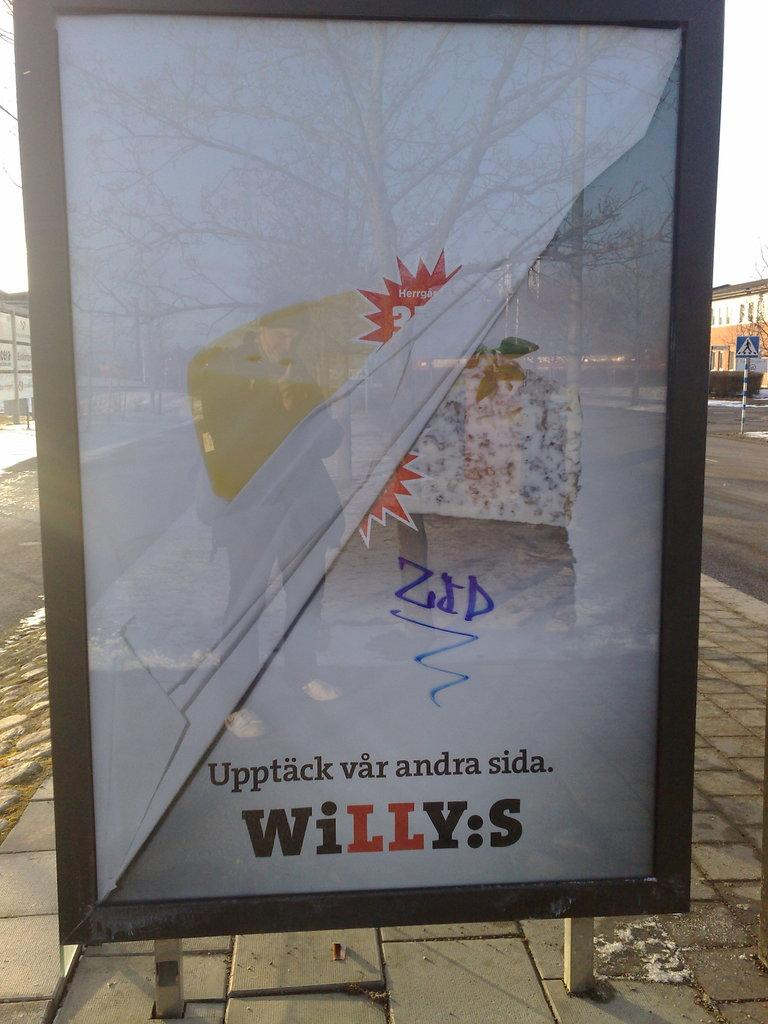Provide a one-sentence caption for the provided image. A bus stop sign for Willy's has a bit of graffiti on it. 